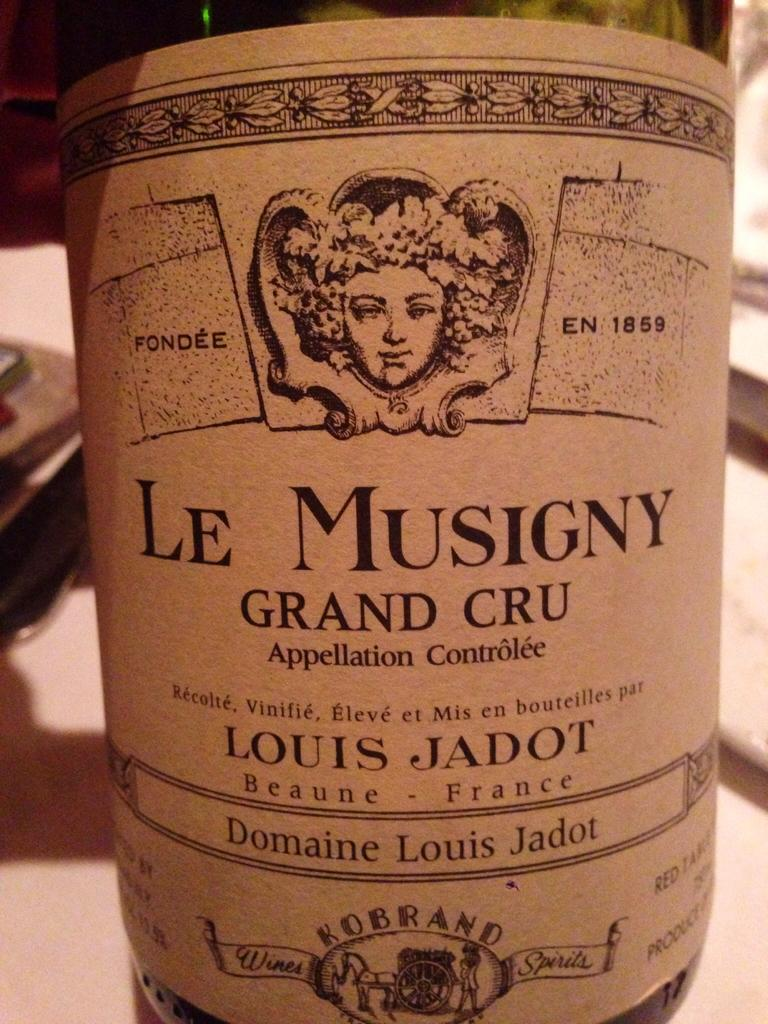What is the main object in the image? There is a liquor bottle in the image. Can you describe the label on the liquor bottle? The label on the liquor bottle has text and a picture on it. What can be said about the background of the image? The background of the image is not clear. What type of education can be seen on the face of the person in the image? There is no person present in the image, so it is not possible to determine their education or any facial features. 